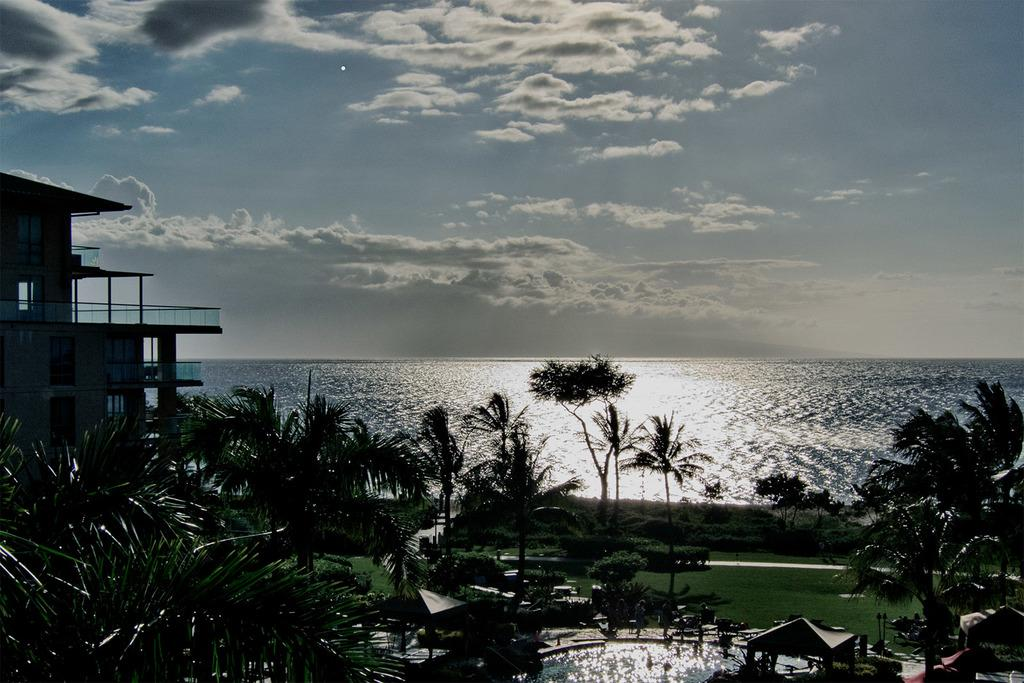What type of structure is present in the image? There is a building in the image. What type of vegetation can be seen in the image? There are trees and grass in the image. What recreational feature is present in the image? There is a swimming pool in the image. What natural feature can be seen in the background of the image? There is a sea visible in the background of the image. Where is the mailbox located in the image? There is no mailbox present in the image. What thing is being shown in the image? The image does not depict a single "thing"; it shows a building, trees, grass, a swimming pool, and a sea. 